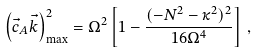Convert formula to latex. <formula><loc_0><loc_0><loc_500><loc_500>\left ( \vec { c } _ { A } \vec { k } \right ) _ { \max } ^ { 2 } = \Omega ^ { 2 } \left [ 1 - \frac { ( - N ^ { 2 } - \kappa ^ { 2 } ) ^ { 2 } } { 1 6 \Omega ^ { 4 } } \right ] \, ,</formula> 